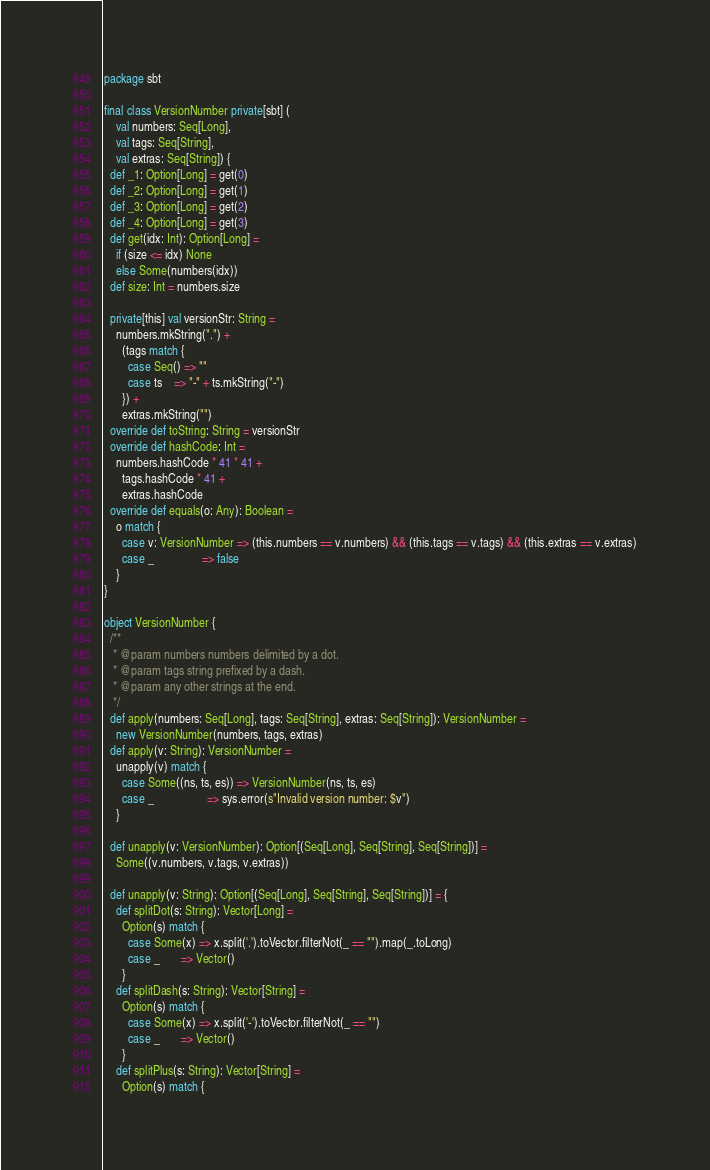Convert code to text. <code><loc_0><loc_0><loc_500><loc_500><_Scala_>package sbt

final class VersionNumber private[sbt] (
    val numbers: Seq[Long],
    val tags: Seq[String],
    val extras: Seq[String]) {
  def _1: Option[Long] = get(0)
  def _2: Option[Long] = get(1)
  def _3: Option[Long] = get(2)
  def _4: Option[Long] = get(3)
  def get(idx: Int): Option[Long] =
    if (size <= idx) None
    else Some(numbers(idx))
  def size: Int = numbers.size

  private[this] val versionStr: String =
    numbers.mkString(".") +
      (tags match {
        case Seq() => ""
        case ts    => "-" + ts.mkString("-")
      }) +
      extras.mkString("")
  override def toString: String = versionStr
  override def hashCode: Int =
    numbers.hashCode * 41 * 41 +
      tags.hashCode * 41 +
      extras.hashCode
  override def equals(o: Any): Boolean =
    o match {
      case v: VersionNumber => (this.numbers == v.numbers) && (this.tags == v.tags) && (this.extras == v.extras)
      case _                => false
    }
}

object VersionNumber {
  /**
   * @param numbers numbers delimited by a dot.
   * @param tags string prefixed by a dash.
   * @param any other strings at the end.
   */
  def apply(numbers: Seq[Long], tags: Seq[String], extras: Seq[String]): VersionNumber =
    new VersionNumber(numbers, tags, extras)
  def apply(v: String): VersionNumber =
    unapply(v) match {
      case Some((ns, ts, es)) => VersionNumber(ns, ts, es)
      case _                  => sys.error(s"Invalid version number: $v")
    }

  def unapply(v: VersionNumber): Option[(Seq[Long], Seq[String], Seq[String])] =
    Some((v.numbers, v.tags, v.extras))

  def unapply(v: String): Option[(Seq[Long], Seq[String], Seq[String])] = {
    def splitDot(s: String): Vector[Long] =
      Option(s) match {
        case Some(x) => x.split('.').toVector.filterNot(_ == "").map(_.toLong)
        case _       => Vector()
      }
    def splitDash(s: String): Vector[String] =
      Option(s) match {
        case Some(x) => x.split('-').toVector.filterNot(_ == "")
        case _       => Vector()
      }
    def splitPlus(s: String): Vector[String] =
      Option(s) match {</code> 